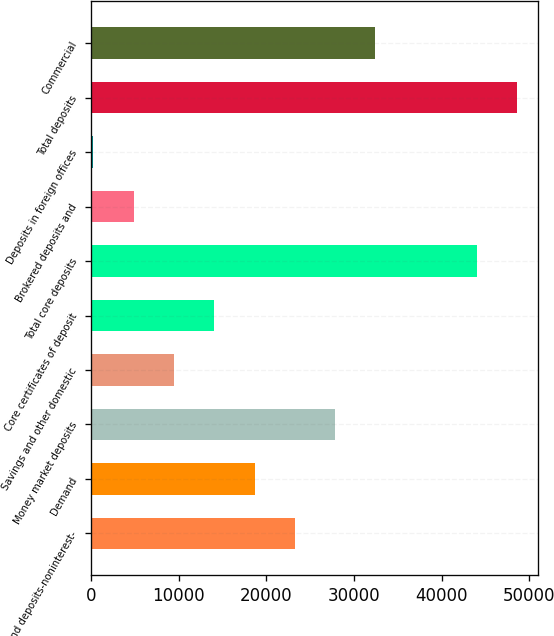Convert chart. <chart><loc_0><loc_0><loc_500><loc_500><bar_chart><fcel>Demand deposits-noninterest-<fcel>Demand<fcel>Money market deposits<fcel>Savings and other domestic<fcel>Core certificates of deposit<fcel>Total core deposits<fcel>Brokered deposits and<fcel>Deposits in foreign offices<fcel>Total deposits<fcel>Commercial<nl><fcel>23265.5<fcel>18668<fcel>27863<fcel>9473<fcel>14070.5<fcel>44027<fcel>4875.5<fcel>278<fcel>48624.5<fcel>32460.5<nl></chart> 